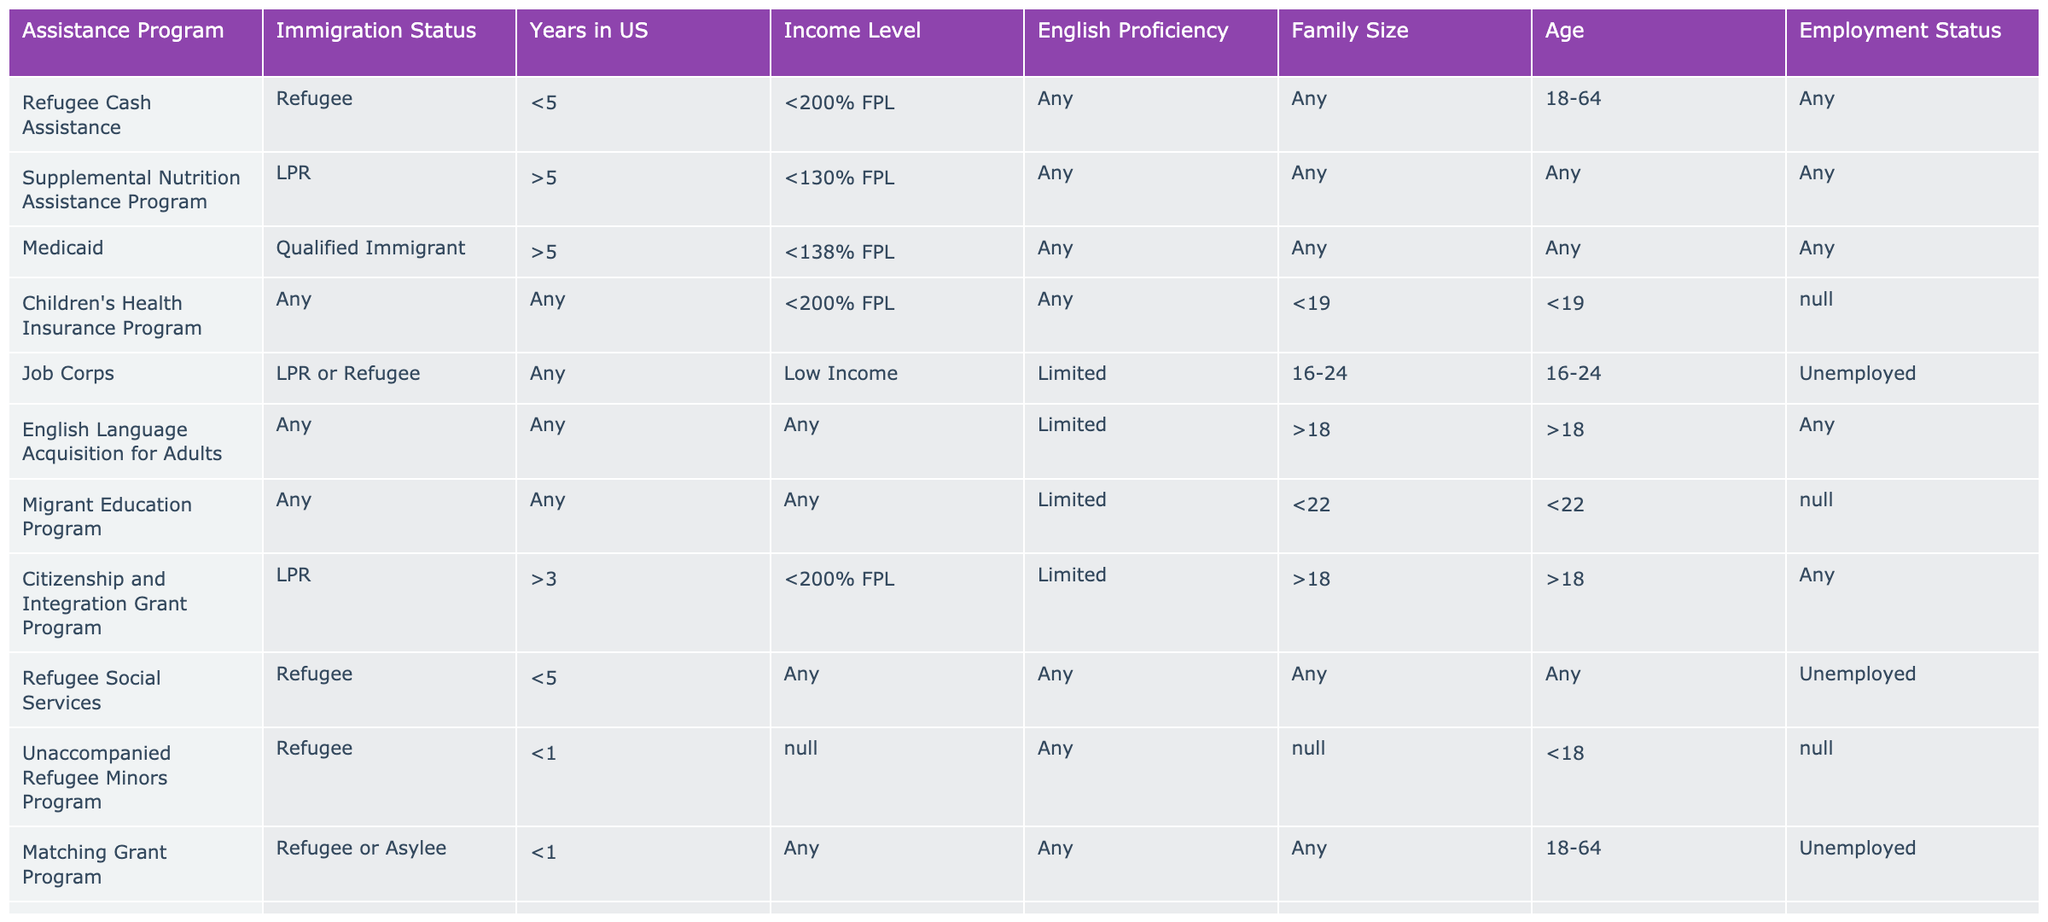What is the income level requirement for the Refugee Cash Assistance program? The Refugee Cash Assistance program requires an income level of less than 200% of the Federal Poverty Level (FPL). This information can be directly found in the "Income Level" column of the corresponding row for this program.
Answer: Less than 200% FPL How many assistance programs require Limited English Proficiency? To find the number of assistance programs requiring Limited English Proficiency, I can count the rows in the table where "English Proficiency" is marked as Limited. These programs are Job Corps, English Language Acquisition for Adults, Migrant Education Program, and others. Counting these gives a total of 4 programs.
Answer: 4 Is it true that the Children's Health Insurance Program is available to any immigration status? Yes, the table indicates that the Children's Health Insurance Program is available to individuals with any immigration status, as specified under "Immigration Status" in the relevant row.
Answer: Yes Which programs are available to refugees who have been in the US for less than one year? By reviewing the table, I find two programs available to refugees who have been in the US for less than one year: the Unaccompanied Refugee Minors Program and the Matching Grant Program. Each of these programs is for refugees with the specified duration of stay.
Answer: Unaccompanied Refugee Minors Program and Matching Grant Program What is the age range eligible for the Job Corps program, and is this program available to both refugees and LPRs? The Job Corps program is available to individuals aged 16-24 and accepts both LPRs (Lawful Permanent Residents) and refugees as stated in the "Age" and "Immigration Status" columns respectively. Therefore, it meets both criteria.
Answer: Ages 16-24; yes Which assistance program has the highest percentage of income level defined as less than 100% FPL? The Head Start program has an income level requirement of less than 100% FPL; it is the only program in this table that specifies this level, making it the highest in terms of this criterion.
Answer: Head Start What is the family size requirement for Temporary Assistance for Needy Families? The Temporary Assistance for Needy Families program requires applicants to have children as indicated under "Family Size" in the corresponding program row. The requirement specifies "With Children".
Answer: With Children Do any of the programs require applicants to be unemployed? Yes, the Job Corps and Refugee Social Services programs both have unemployment as a requirement, as indicated in their respective "Employment Status" columns.
Answer: Yes 